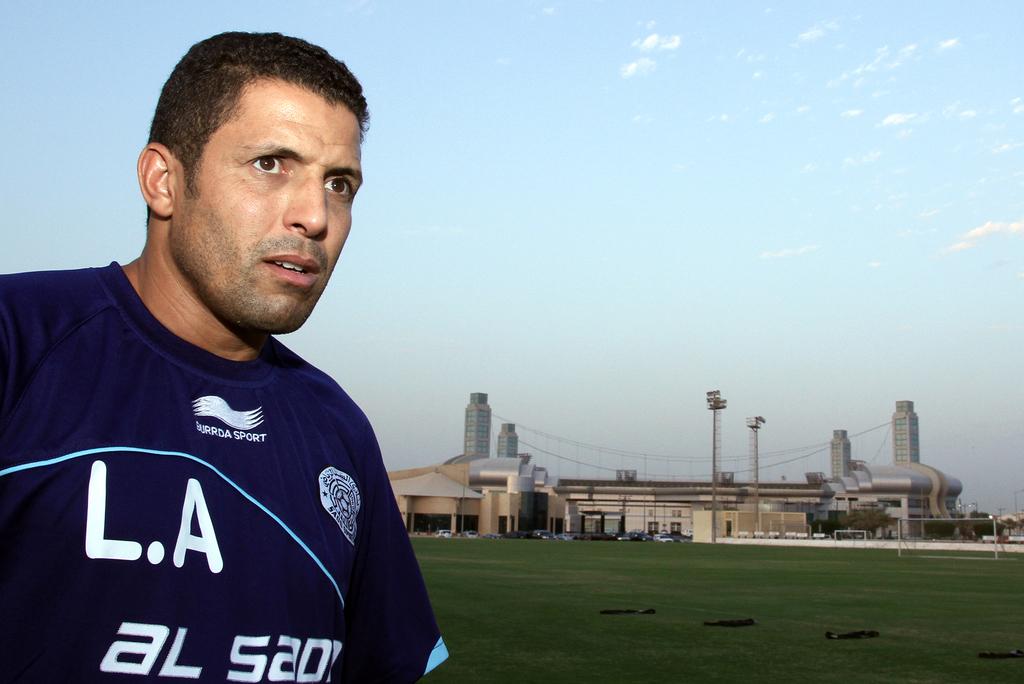Does his shirt say la on it?
Your answer should be very brief. Yes. Who created this jersey?
Your response must be concise. Burrda sport. 